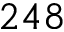<formula> <loc_0><loc_0><loc_500><loc_500>2 4 8</formula> 